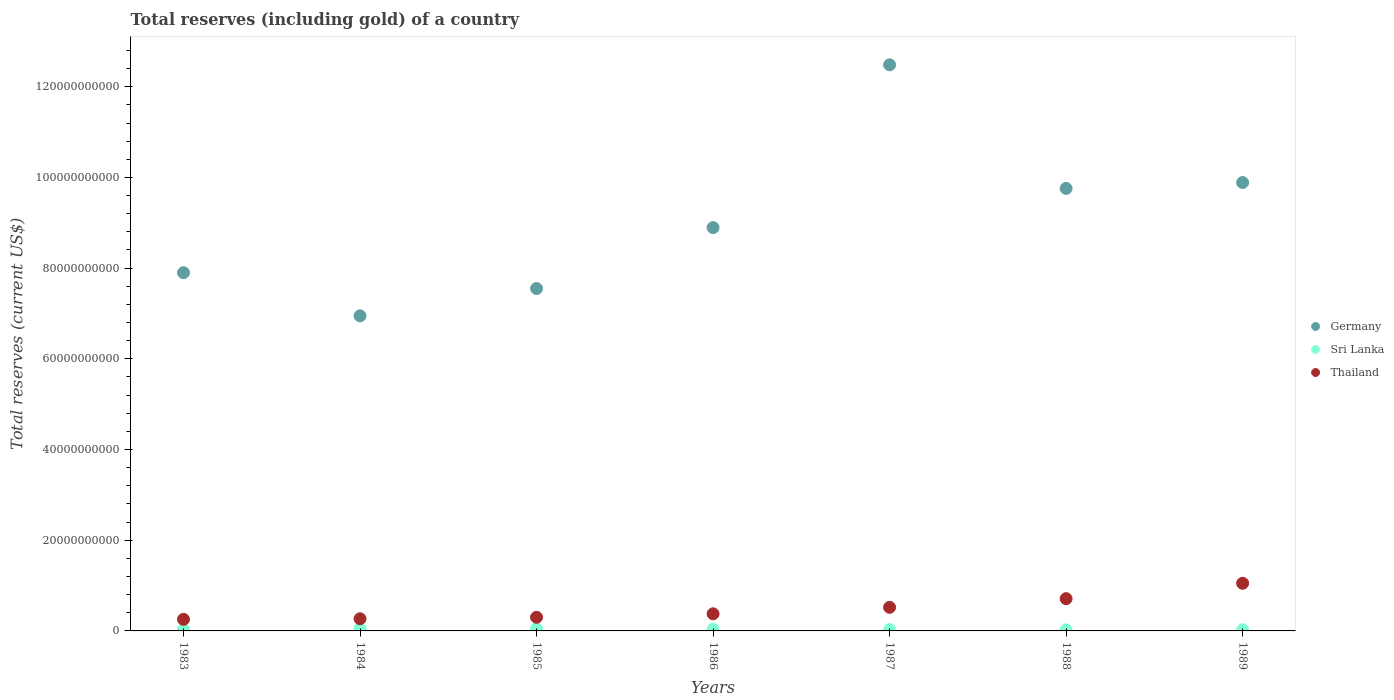Is the number of dotlines equal to the number of legend labels?
Provide a short and direct response. Yes. What is the total reserves (including gold) in Thailand in 1983?
Provide a succinct answer. 2.56e+09. Across all years, what is the maximum total reserves (including gold) in Sri Lanka?
Offer a very short reply. 5.30e+08. Across all years, what is the minimum total reserves (including gold) in Germany?
Your answer should be compact. 6.95e+1. In which year was the total reserves (including gold) in Sri Lanka maximum?
Provide a short and direct response. 1984. In which year was the total reserves (including gold) in Germany minimum?
Your response must be concise. 1984. What is the total total reserves (including gold) in Thailand in the graph?
Your answer should be very brief. 3.48e+1. What is the difference between the total reserves (including gold) in Sri Lanka in 1984 and that in 1986?
Offer a very short reply. 1.53e+08. What is the difference between the total reserves (including gold) in Germany in 1985 and the total reserves (including gold) in Thailand in 1984?
Your answer should be compact. 7.28e+1. What is the average total reserves (including gold) in Thailand per year?
Offer a terse response. 4.98e+09. In the year 1988, what is the difference between the total reserves (including gold) in Sri Lanka and total reserves (including gold) in Germany?
Make the answer very short. -9.73e+1. In how many years, is the total reserves (including gold) in Thailand greater than 8000000000 US$?
Your response must be concise. 1. What is the ratio of the total reserves (including gold) in Sri Lanka in 1986 to that in 1988?
Your answer should be compact. 1.52. What is the difference between the highest and the second highest total reserves (including gold) in Sri Lanka?
Your answer should be compact. 5.84e+07. What is the difference between the highest and the lowest total reserves (including gold) in Sri Lanka?
Your answer should be very brief. 2.82e+08. Is the sum of the total reserves (including gold) in Thailand in 1983 and 1989 greater than the maximum total reserves (including gold) in Sri Lanka across all years?
Give a very brief answer. Yes. Does the total reserves (including gold) in Thailand monotonically increase over the years?
Provide a succinct answer. Yes. How many years are there in the graph?
Offer a very short reply. 7. Does the graph contain any zero values?
Your answer should be compact. No. Does the graph contain grids?
Provide a succinct answer. No. How many legend labels are there?
Offer a terse response. 3. How are the legend labels stacked?
Your response must be concise. Vertical. What is the title of the graph?
Offer a very short reply. Total reserves (including gold) of a country. What is the label or title of the Y-axis?
Offer a terse response. Total reserves (current US$). What is the Total reserves (current US$) of Germany in 1983?
Your response must be concise. 7.90e+1. What is the Total reserves (current US$) in Sri Lanka in 1983?
Offer a very short reply. 3.21e+08. What is the Total reserves (current US$) in Thailand in 1983?
Offer a terse response. 2.56e+09. What is the Total reserves (current US$) of Germany in 1984?
Provide a short and direct response. 6.95e+1. What is the Total reserves (current US$) of Sri Lanka in 1984?
Your answer should be compact. 5.30e+08. What is the Total reserves (current US$) of Thailand in 1984?
Give a very brief answer. 2.69e+09. What is the Total reserves (current US$) of Germany in 1985?
Give a very brief answer. 7.55e+1. What is the Total reserves (current US$) in Sri Lanka in 1985?
Ensure brevity in your answer.  4.72e+08. What is the Total reserves (current US$) in Thailand in 1985?
Offer a terse response. 3.00e+09. What is the Total reserves (current US$) of Germany in 1986?
Offer a very short reply. 8.89e+1. What is the Total reserves (current US$) of Sri Lanka in 1986?
Your response must be concise. 3.77e+08. What is the Total reserves (current US$) of Thailand in 1986?
Give a very brief answer. 3.78e+09. What is the Total reserves (current US$) in Germany in 1987?
Provide a succinct answer. 1.25e+11. What is the Total reserves (current US$) of Sri Lanka in 1987?
Make the answer very short. 3.10e+08. What is the Total reserves (current US$) of Thailand in 1987?
Offer a terse response. 5.21e+09. What is the Total reserves (current US$) of Germany in 1988?
Your response must be concise. 9.76e+1. What is the Total reserves (current US$) in Sri Lanka in 1988?
Your answer should be very brief. 2.48e+08. What is the Total reserves (current US$) in Thailand in 1988?
Provide a succinct answer. 7.11e+09. What is the Total reserves (current US$) of Germany in 1989?
Your answer should be compact. 9.89e+1. What is the Total reserves (current US$) in Sri Lanka in 1989?
Ensure brevity in your answer.  2.69e+08. What is the Total reserves (current US$) in Thailand in 1989?
Provide a succinct answer. 1.05e+1. Across all years, what is the maximum Total reserves (current US$) in Germany?
Your answer should be compact. 1.25e+11. Across all years, what is the maximum Total reserves (current US$) in Sri Lanka?
Your response must be concise. 5.30e+08. Across all years, what is the maximum Total reserves (current US$) of Thailand?
Give a very brief answer. 1.05e+1. Across all years, what is the minimum Total reserves (current US$) of Germany?
Offer a terse response. 6.95e+1. Across all years, what is the minimum Total reserves (current US$) in Sri Lanka?
Give a very brief answer. 2.48e+08. Across all years, what is the minimum Total reserves (current US$) in Thailand?
Keep it short and to the point. 2.56e+09. What is the total Total reserves (current US$) of Germany in the graph?
Give a very brief answer. 6.34e+11. What is the total Total reserves (current US$) in Sri Lanka in the graph?
Provide a short and direct response. 2.53e+09. What is the total Total reserves (current US$) in Thailand in the graph?
Offer a terse response. 3.48e+1. What is the difference between the Total reserves (current US$) in Germany in 1983 and that in 1984?
Your answer should be compact. 9.50e+09. What is the difference between the Total reserves (current US$) in Sri Lanka in 1983 and that in 1984?
Ensure brevity in your answer.  -2.09e+08. What is the difference between the Total reserves (current US$) of Thailand in 1983 and that in 1984?
Offer a terse response. -1.31e+08. What is the difference between the Total reserves (current US$) of Germany in 1983 and that in 1985?
Make the answer very short. 3.48e+09. What is the difference between the Total reserves (current US$) of Sri Lanka in 1983 and that in 1985?
Ensure brevity in your answer.  -1.51e+08. What is the difference between the Total reserves (current US$) of Thailand in 1983 and that in 1985?
Your response must be concise. -4.47e+08. What is the difference between the Total reserves (current US$) in Germany in 1983 and that in 1986?
Provide a short and direct response. -9.95e+09. What is the difference between the Total reserves (current US$) in Sri Lanka in 1983 and that in 1986?
Make the answer very short. -5.62e+07. What is the difference between the Total reserves (current US$) of Thailand in 1983 and that in 1986?
Provide a short and direct response. -1.22e+09. What is the difference between the Total reserves (current US$) in Germany in 1983 and that in 1987?
Ensure brevity in your answer.  -4.58e+1. What is the difference between the Total reserves (current US$) of Sri Lanka in 1983 and that in 1987?
Ensure brevity in your answer.  1.14e+07. What is the difference between the Total reserves (current US$) in Thailand in 1983 and that in 1987?
Offer a very short reply. -2.65e+09. What is the difference between the Total reserves (current US$) in Germany in 1983 and that in 1988?
Your answer should be very brief. -1.86e+1. What is the difference between the Total reserves (current US$) in Sri Lanka in 1983 and that in 1988?
Provide a succinct answer. 7.32e+07. What is the difference between the Total reserves (current US$) of Thailand in 1983 and that in 1988?
Provide a short and direct response. -4.56e+09. What is the difference between the Total reserves (current US$) of Germany in 1983 and that in 1989?
Provide a short and direct response. -1.99e+1. What is the difference between the Total reserves (current US$) in Sri Lanka in 1983 and that in 1989?
Your answer should be compact. 5.15e+07. What is the difference between the Total reserves (current US$) of Thailand in 1983 and that in 1989?
Keep it short and to the point. -7.95e+09. What is the difference between the Total reserves (current US$) of Germany in 1984 and that in 1985?
Your answer should be very brief. -6.02e+09. What is the difference between the Total reserves (current US$) in Sri Lanka in 1984 and that in 1985?
Provide a succinct answer. 5.84e+07. What is the difference between the Total reserves (current US$) of Thailand in 1984 and that in 1985?
Provide a short and direct response. -3.16e+08. What is the difference between the Total reserves (current US$) in Germany in 1984 and that in 1986?
Provide a succinct answer. -1.95e+1. What is the difference between the Total reserves (current US$) of Sri Lanka in 1984 and that in 1986?
Give a very brief answer. 1.53e+08. What is the difference between the Total reserves (current US$) of Thailand in 1984 and that in 1986?
Provide a succinct answer. -1.09e+09. What is the difference between the Total reserves (current US$) in Germany in 1984 and that in 1987?
Provide a short and direct response. -5.53e+1. What is the difference between the Total reserves (current US$) in Sri Lanka in 1984 and that in 1987?
Provide a short and direct response. 2.21e+08. What is the difference between the Total reserves (current US$) in Thailand in 1984 and that in 1987?
Give a very brief answer. -2.52e+09. What is the difference between the Total reserves (current US$) in Germany in 1984 and that in 1988?
Your answer should be compact. -2.81e+1. What is the difference between the Total reserves (current US$) of Sri Lanka in 1984 and that in 1988?
Provide a short and direct response. 2.82e+08. What is the difference between the Total reserves (current US$) of Thailand in 1984 and that in 1988?
Your answer should be compact. -4.43e+09. What is the difference between the Total reserves (current US$) in Germany in 1984 and that in 1989?
Your answer should be compact. -2.94e+1. What is the difference between the Total reserves (current US$) of Sri Lanka in 1984 and that in 1989?
Offer a terse response. 2.61e+08. What is the difference between the Total reserves (current US$) of Thailand in 1984 and that in 1989?
Ensure brevity in your answer.  -7.82e+09. What is the difference between the Total reserves (current US$) in Germany in 1985 and that in 1986?
Offer a very short reply. -1.34e+1. What is the difference between the Total reserves (current US$) in Sri Lanka in 1985 and that in 1986?
Provide a short and direct response. 9.45e+07. What is the difference between the Total reserves (current US$) of Thailand in 1985 and that in 1986?
Your answer should be very brief. -7.73e+08. What is the difference between the Total reserves (current US$) in Germany in 1985 and that in 1987?
Your answer should be compact. -4.93e+1. What is the difference between the Total reserves (current US$) of Sri Lanka in 1985 and that in 1987?
Your answer should be compact. 1.62e+08. What is the difference between the Total reserves (current US$) of Thailand in 1985 and that in 1987?
Offer a very short reply. -2.20e+09. What is the difference between the Total reserves (current US$) in Germany in 1985 and that in 1988?
Keep it short and to the point. -2.21e+1. What is the difference between the Total reserves (current US$) in Sri Lanka in 1985 and that in 1988?
Offer a very short reply. 2.24e+08. What is the difference between the Total reserves (current US$) of Thailand in 1985 and that in 1988?
Ensure brevity in your answer.  -4.11e+09. What is the difference between the Total reserves (current US$) of Germany in 1985 and that in 1989?
Your response must be concise. -2.34e+1. What is the difference between the Total reserves (current US$) in Sri Lanka in 1985 and that in 1989?
Give a very brief answer. 2.02e+08. What is the difference between the Total reserves (current US$) of Thailand in 1985 and that in 1989?
Your answer should be very brief. -7.50e+09. What is the difference between the Total reserves (current US$) of Germany in 1986 and that in 1987?
Provide a short and direct response. -3.59e+1. What is the difference between the Total reserves (current US$) in Sri Lanka in 1986 and that in 1987?
Your answer should be compact. 6.77e+07. What is the difference between the Total reserves (current US$) in Thailand in 1986 and that in 1987?
Provide a succinct answer. -1.43e+09. What is the difference between the Total reserves (current US$) in Germany in 1986 and that in 1988?
Make the answer very short. -8.64e+09. What is the difference between the Total reserves (current US$) of Sri Lanka in 1986 and that in 1988?
Give a very brief answer. 1.29e+08. What is the difference between the Total reserves (current US$) of Thailand in 1986 and that in 1988?
Provide a short and direct response. -3.34e+09. What is the difference between the Total reserves (current US$) in Germany in 1986 and that in 1989?
Your response must be concise. -9.94e+09. What is the difference between the Total reserves (current US$) of Sri Lanka in 1986 and that in 1989?
Make the answer very short. 1.08e+08. What is the difference between the Total reserves (current US$) of Thailand in 1986 and that in 1989?
Your response must be concise. -6.73e+09. What is the difference between the Total reserves (current US$) in Germany in 1987 and that in 1988?
Your answer should be very brief. 2.73e+1. What is the difference between the Total reserves (current US$) of Sri Lanka in 1987 and that in 1988?
Make the answer very short. 6.18e+07. What is the difference between the Total reserves (current US$) in Thailand in 1987 and that in 1988?
Give a very brief answer. -1.91e+09. What is the difference between the Total reserves (current US$) in Germany in 1987 and that in 1989?
Offer a very short reply. 2.60e+1. What is the difference between the Total reserves (current US$) in Sri Lanka in 1987 and that in 1989?
Make the answer very short. 4.01e+07. What is the difference between the Total reserves (current US$) of Thailand in 1987 and that in 1989?
Your response must be concise. -5.30e+09. What is the difference between the Total reserves (current US$) of Germany in 1988 and that in 1989?
Ensure brevity in your answer.  -1.30e+09. What is the difference between the Total reserves (current US$) in Sri Lanka in 1988 and that in 1989?
Offer a terse response. -2.17e+07. What is the difference between the Total reserves (current US$) of Thailand in 1988 and that in 1989?
Keep it short and to the point. -3.40e+09. What is the difference between the Total reserves (current US$) of Germany in 1983 and the Total reserves (current US$) of Sri Lanka in 1984?
Your response must be concise. 7.85e+1. What is the difference between the Total reserves (current US$) of Germany in 1983 and the Total reserves (current US$) of Thailand in 1984?
Your response must be concise. 7.63e+1. What is the difference between the Total reserves (current US$) in Sri Lanka in 1983 and the Total reserves (current US$) in Thailand in 1984?
Your answer should be compact. -2.37e+09. What is the difference between the Total reserves (current US$) of Germany in 1983 and the Total reserves (current US$) of Sri Lanka in 1985?
Give a very brief answer. 7.85e+1. What is the difference between the Total reserves (current US$) in Germany in 1983 and the Total reserves (current US$) in Thailand in 1985?
Your answer should be compact. 7.60e+1. What is the difference between the Total reserves (current US$) of Sri Lanka in 1983 and the Total reserves (current US$) of Thailand in 1985?
Provide a succinct answer. -2.68e+09. What is the difference between the Total reserves (current US$) in Germany in 1983 and the Total reserves (current US$) in Sri Lanka in 1986?
Offer a very short reply. 7.86e+1. What is the difference between the Total reserves (current US$) in Germany in 1983 and the Total reserves (current US$) in Thailand in 1986?
Ensure brevity in your answer.  7.52e+1. What is the difference between the Total reserves (current US$) of Sri Lanka in 1983 and the Total reserves (current US$) of Thailand in 1986?
Your response must be concise. -3.46e+09. What is the difference between the Total reserves (current US$) in Germany in 1983 and the Total reserves (current US$) in Sri Lanka in 1987?
Your response must be concise. 7.87e+1. What is the difference between the Total reserves (current US$) of Germany in 1983 and the Total reserves (current US$) of Thailand in 1987?
Offer a terse response. 7.38e+1. What is the difference between the Total reserves (current US$) of Sri Lanka in 1983 and the Total reserves (current US$) of Thailand in 1987?
Give a very brief answer. -4.88e+09. What is the difference between the Total reserves (current US$) of Germany in 1983 and the Total reserves (current US$) of Sri Lanka in 1988?
Make the answer very short. 7.87e+1. What is the difference between the Total reserves (current US$) in Germany in 1983 and the Total reserves (current US$) in Thailand in 1988?
Provide a short and direct response. 7.19e+1. What is the difference between the Total reserves (current US$) in Sri Lanka in 1983 and the Total reserves (current US$) in Thailand in 1988?
Your response must be concise. -6.79e+09. What is the difference between the Total reserves (current US$) of Germany in 1983 and the Total reserves (current US$) of Sri Lanka in 1989?
Keep it short and to the point. 7.87e+1. What is the difference between the Total reserves (current US$) of Germany in 1983 and the Total reserves (current US$) of Thailand in 1989?
Provide a succinct answer. 6.85e+1. What is the difference between the Total reserves (current US$) in Sri Lanka in 1983 and the Total reserves (current US$) in Thailand in 1989?
Offer a terse response. -1.02e+1. What is the difference between the Total reserves (current US$) of Germany in 1984 and the Total reserves (current US$) of Sri Lanka in 1985?
Ensure brevity in your answer.  6.90e+1. What is the difference between the Total reserves (current US$) in Germany in 1984 and the Total reserves (current US$) in Thailand in 1985?
Ensure brevity in your answer.  6.65e+1. What is the difference between the Total reserves (current US$) of Sri Lanka in 1984 and the Total reserves (current US$) of Thailand in 1985?
Offer a terse response. -2.47e+09. What is the difference between the Total reserves (current US$) in Germany in 1984 and the Total reserves (current US$) in Sri Lanka in 1986?
Keep it short and to the point. 6.91e+1. What is the difference between the Total reserves (current US$) of Germany in 1984 and the Total reserves (current US$) of Thailand in 1986?
Keep it short and to the point. 6.57e+1. What is the difference between the Total reserves (current US$) of Sri Lanka in 1984 and the Total reserves (current US$) of Thailand in 1986?
Provide a short and direct response. -3.25e+09. What is the difference between the Total reserves (current US$) of Germany in 1984 and the Total reserves (current US$) of Sri Lanka in 1987?
Keep it short and to the point. 6.92e+1. What is the difference between the Total reserves (current US$) in Germany in 1984 and the Total reserves (current US$) in Thailand in 1987?
Ensure brevity in your answer.  6.43e+1. What is the difference between the Total reserves (current US$) of Sri Lanka in 1984 and the Total reserves (current US$) of Thailand in 1987?
Offer a very short reply. -4.68e+09. What is the difference between the Total reserves (current US$) in Germany in 1984 and the Total reserves (current US$) in Sri Lanka in 1988?
Your answer should be compact. 6.92e+1. What is the difference between the Total reserves (current US$) in Germany in 1984 and the Total reserves (current US$) in Thailand in 1988?
Your response must be concise. 6.24e+1. What is the difference between the Total reserves (current US$) of Sri Lanka in 1984 and the Total reserves (current US$) of Thailand in 1988?
Provide a short and direct response. -6.58e+09. What is the difference between the Total reserves (current US$) in Germany in 1984 and the Total reserves (current US$) in Sri Lanka in 1989?
Keep it short and to the point. 6.92e+1. What is the difference between the Total reserves (current US$) in Germany in 1984 and the Total reserves (current US$) in Thailand in 1989?
Keep it short and to the point. 5.90e+1. What is the difference between the Total reserves (current US$) in Sri Lanka in 1984 and the Total reserves (current US$) in Thailand in 1989?
Offer a terse response. -9.98e+09. What is the difference between the Total reserves (current US$) of Germany in 1985 and the Total reserves (current US$) of Sri Lanka in 1986?
Offer a terse response. 7.51e+1. What is the difference between the Total reserves (current US$) in Germany in 1985 and the Total reserves (current US$) in Thailand in 1986?
Provide a succinct answer. 7.17e+1. What is the difference between the Total reserves (current US$) in Sri Lanka in 1985 and the Total reserves (current US$) in Thailand in 1986?
Give a very brief answer. -3.30e+09. What is the difference between the Total reserves (current US$) in Germany in 1985 and the Total reserves (current US$) in Sri Lanka in 1987?
Provide a short and direct response. 7.52e+1. What is the difference between the Total reserves (current US$) of Germany in 1985 and the Total reserves (current US$) of Thailand in 1987?
Make the answer very short. 7.03e+1. What is the difference between the Total reserves (current US$) in Sri Lanka in 1985 and the Total reserves (current US$) in Thailand in 1987?
Your response must be concise. -4.73e+09. What is the difference between the Total reserves (current US$) of Germany in 1985 and the Total reserves (current US$) of Sri Lanka in 1988?
Your answer should be very brief. 7.53e+1. What is the difference between the Total reserves (current US$) in Germany in 1985 and the Total reserves (current US$) in Thailand in 1988?
Provide a succinct answer. 6.84e+1. What is the difference between the Total reserves (current US$) of Sri Lanka in 1985 and the Total reserves (current US$) of Thailand in 1988?
Your answer should be compact. -6.64e+09. What is the difference between the Total reserves (current US$) in Germany in 1985 and the Total reserves (current US$) in Sri Lanka in 1989?
Make the answer very short. 7.52e+1. What is the difference between the Total reserves (current US$) in Germany in 1985 and the Total reserves (current US$) in Thailand in 1989?
Offer a very short reply. 6.50e+1. What is the difference between the Total reserves (current US$) in Sri Lanka in 1985 and the Total reserves (current US$) in Thailand in 1989?
Keep it short and to the point. -1.00e+1. What is the difference between the Total reserves (current US$) in Germany in 1986 and the Total reserves (current US$) in Sri Lanka in 1987?
Your answer should be very brief. 8.86e+1. What is the difference between the Total reserves (current US$) in Germany in 1986 and the Total reserves (current US$) in Thailand in 1987?
Keep it short and to the point. 8.37e+1. What is the difference between the Total reserves (current US$) in Sri Lanka in 1986 and the Total reserves (current US$) in Thailand in 1987?
Offer a very short reply. -4.83e+09. What is the difference between the Total reserves (current US$) in Germany in 1986 and the Total reserves (current US$) in Sri Lanka in 1988?
Offer a terse response. 8.87e+1. What is the difference between the Total reserves (current US$) in Germany in 1986 and the Total reserves (current US$) in Thailand in 1988?
Ensure brevity in your answer.  8.18e+1. What is the difference between the Total reserves (current US$) in Sri Lanka in 1986 and the Total reserves (current US$) in Thailand in 1988?
Your answer should be compact. -6.74e+09. What is the difference between the Total reserves (current US$) in Germany in 1986 and the Total reserves (current US$) in Sri Lanka in 1989?
Your answer should be compact. 8.87e+1. What is the difference between the Total reserves (current US$) in Germany in 1986 and the Total reserves (current US$) in Thailand in 1989?
Your response must be concise. 7.84e+1. What is the difference between the Total reserves (current US$) of Sri Lanka in 1986 and the Total reserves (current US$) of Thailand in 1989?
Your answer should be very brief. -1.01e+1. What is the difference between the Total reserves (current US$) of Germany in 1987 and the Total reserves (current US$) of Sri Lanka in 1988?
Keep it short and to the point. 1.25e+11. What is the difference between the Total reserves (current US$) of Germany in 1987 and the Total reserves (current US$) of Thailand in 1988?
Provide a short and direct response. 1.18e+11. What is the difference between the Total reserves (current US$) in Sri Lanka in 1987 and the Total reserves (current US$) in Thailand in 1988?
Offer a terse response. -6.80e+09. What is the difference between the Total reserves (current US$) of Germany in 1987 and the Total reserves (current US$) of Sri Lanka in 1989?
Ensure brevity in your answer.  1.25e+11. What is the difference between the Total reserves (current US$) in Germany in 1987 and the Total reserves (current US$) in Thailand in 1989?
Your response must be concise. 1.14e+11. What is the difference between the Total reserves (current US$) of Sri Lanka in 1987 and the Total reserves (current US$) of Thailand in 1989?
Provide a short and direct response. -1.02e+1. What is the difference between the Total reserves (current US$) in Germany in 1988 and the Total reserves (current US$) in Sri Lanka in 1989?
Give a very brief answer. 9.73e+1. What is the difference between the Total reserves (current US$) in Germany in 1988 and the Total reserves (current US$) in Thailand in 1989?
Offer a very short reply. 8.71e+1. What is the difference between the Total reserves (current US$) in Sri Lanka in 1988 and the Total reserves (current US$) in Thailand in 1989?
Offer a terse response. -1.03e+1. What is the average Total reserves (current US$) in Germany per year?
Your answer should be compact. 9.06e+1. What is the average Total reserves (current US$) in Sri Lanka per year?
Provide a succinct answer. 3.61e+08. What is the average Total reserves (current US$) in Thailand per year?
Keep it short and to the point. 4.98e+09. In the year 1983, what is the difference between the Total reserves (current US$) in Germany and Total reserves (current US$) in Sri Lanka?
Your answer should be compact. 7.87e+1. In the year 1983, what is the difference between the Total reserves (current US$) in Germany and Total reserves (current US$) in Thailand?
Your answer should be very brief. 7.64e+1. In the year 1983, what is the difference between the Total reserves (current US$) of Sri Lanka and Total reserves (current US$) of Thailand?
Your answer should be very brief. -2.23e+09. In the year 1984, what is the difference between the Total reserves (current US$) in Germany and Total reserves (current US$) in Sri Lanka?
Offer a terse response. 6.90e+1. In the year 1984, what is the difference between the Total reserves (current US$) of Germany and Total reserves (current US$) of Thailand?
Your answer should be very brief. 6.68e+1. In the year 1984, what is the difference between the Total reserves (current US$) in Sri Lanka and Total reserves (current US$) in Thailand?
Your response must be concise. -2.16e+09. In the year 1985, what is the difference between the Total reserves (current US$) in Germany and Total reserves (current US$) in Sri Lanka?
Provide a succinct answer. 7.50e+1. In the year 1985, what is the difference between the Total reserves (current US$) of Germany and Total reserves (current US$) of Thailand?
Provide a short and direct response. 7.25e+1. In the year 1985, what is the difference between the Total reserves (current US$) of Sri Lanka and Total reserves (current US$) of Thailand?
Make the answer very short. -2.53e+09. In the year 1986, what is the difference between the Total reserves (current US$) of Germany and Total reserves (current US$) of Sri Lanka?
Offer a very short reply. 8.86e+1. In the year 1986, what is the difference between the Total reserves (current US$) of Germany and Total reserves (current US$) of Thailand?
Your response must be concise. 8.52e+1. In the year 1986, what is the difference between the Total reserves (current US$) of Sri Lanka and Total reserves (current US$) of Thailand?
Provide a succinct answer. -3.40e+09. In the year 1987, what is the difference between the Total reserves (current US$) of Germany and Total reserves (current US$) of Sri Lanka?
Provide a succinct answer. 1.25e+11. In the year 1987, what is the difference between the Total reserves (current US$) of Germany and Total reserves (current US$) of Thailand?
Give a very brief answer. 1.20e+11. In the year 1987, what is the difference between the Total reserves (current US$) of Sri Lanka and Total reserves (current US$) of Thailand?
Your answer should be compact. -4.90e+09. In the year 1988, what is the difference between the Total reserves (current US$) of Germany and Total reserves (current US$) of Sri Lanka?
Offer a terse response. 9.73e+1. In the year 1988, what is the difference between the Total reserves (current US$) of Germany and Total reserves (current US$) of Thailand?
Your response must be concise. 9.05e+1. In the year 1988, what is the difference between the Total reserves (current US$) of Sri Lanka and Total reserves (current US$) of Thailand?
Ensure brevity in your answer.  -6.86e+09. In the year 1989, what is the difference between the Total reserves (current US$) of Germany and Total reserves (current US$) of Sri Lanka?
Your answer should be compact. 9.86e+1. In the year 1989, what is the difference between the Total reserves (current US$) of Germany and Total reserves (current US$) of Thailand?
Provide a short and direct response. 8.84e+1. In the year 1989, what is the difference between the Total reserves (current US$) of Sri Lanka and Total reserves (current US$) of Thailand?
Offer a terse response. -1.02e+1. What is the ratio of the Total reserves (current US$) in Germany in 1983 to that in 1984?
Keep it short and to the point. 1.14. What is the ratio of the Total reserves (current US$) of Sri Lanka in 1983 to that in 1984?
Provide a short and direct response. 0.61. What is the ratio of the Total reserves (current US$) in Thailand in 1983 to that in 1984?
Ensure brevity in your answer.  0.95. What is the ratio of the Total reserves (current US$) in Germany in 1983 to that in 1985?
Offer a very short reply. 1.05. What is the ratio of the Total reserves (current US$) of Sri Lanka in 1983 to that in 1985?
Your answer should be compact. 0.68. What is the ratio of the Total reserves (current US$) of Thailand in 1983 to that in 1985?
Provide a short and direct response. 0.85. What is the ratio of the Total reserves (current US$) of Germany in 1983 to that in 1986?
Provide a succinct answer. 0.89. What is the ratio of the Total reserves (current US$) in Sri Lanka in 1983 to that in 1986?
Your answer should be compact. 0.85. What is the ratio of the Total reserves (current US$) in Thailand in 1983 to that in 1986?
Keep it short and to the point. 0.68. What is the ratio of the Total reserves (current US$) in Germany in 1983 to that in 1987?
Your answer should be compact. 0.63. What is the ratio of the Total reserves (current US$) of Thailand in 1983 to that in 1987?
Your answer should be very brief. 0.49. What is the ratio of the Total reserves (current US$) of Germany in 1983 to that in 1988?
Provide a short and direct response. 0.81. What is the ratio of the Total reserves (current US$) in Sri Lanka in 1983 to that in 1988?
Your answer should be compact. 1.3. What is the ratio of the Total reserves (current US$) of Thailand in 1983 to that in 1988?
Your response must be concise. 0.36. What is the ratio of the Total reserves (current US$) of Germany in 1983 to that in 1989?
Your answer should be compact. 0.8. What is the ratio of the Total reserves (current US$) of Sri Lanka in 1983 to that in 1989?
Offer a terse response. 1.19. What is the ratio of the Total reserves (current US$) of Thailand in 1983 to that in 1989?
Offer a terse response. 0.24. What is the ratio of the Total reserves (current US$) of Germany in 1984 to that in 1985?
Keep it short and to the point. 0.92. What is the ratio of the Total reserves (current US$) of Sri Lanka in 1984 to that in 1985?
Your answer should be compact. 1.12. What is the ratio of the Total reserves (current US$) of Thailand in 1984 to that in 1985?
Your response must be concise. 0.89. What is the ratio of the Total reserves (current US$) in Germany in 1984 to that in 1986?
Offer a very short reply. 0.78. What is the ratio of the Total reserves (current US$) in Sri Lanka in 1984 to that in 1986?
Your answer should be compact. 1.41. What is the ratio of the Total reserves (current US$) in Thailand in 1984 to that in 1986?
Your response must be concise. 0.71. What is the ratio of the Total reserves (current US$) of Germany in 1984 to that in 1987?
Make the answer very short. 0.56. What is the ratio of the Total reserves (current US$) in Sri Lanka in 1984 to that in 1987?
Give a very brief answer. 1.71. What is the ratio of the Total reserves (current US$) of Thailand in 1984 to that in 1987?
Make the answer very short. 0.52. What is the ratio of the Total reserves (current US$) of Germany in 1984 to that in 1988?
Offer a terse response. 0.71. What is the ratio of the Total reserves (current US$) in Sri Lanka in 1984 to that in 1988?
Provide a short and direct response. 2.14. What is the ratio of the Total reserves (current US$) in Thailand in 1984 to that in 1988?
Offer a very short reply. 0.38. What is the ratio of the Total reserves (current US$) in Germany in 1984 to that in 1989?
Your response must be concise. 0.7. What is the ratio of the Total reserves (current US$) in Sri Lanka in 1984 to that in 1989?
Provide a short and direct response. 1.97. What is the ratio of the Total reserves (current US$) in Thailand in 1984 to that in 1989?
Ensure brevity in your answer.  0.26. What is the ratio of the Total reserves (current US$) of Germany in 1985 to that in 1986?
Your response must be concise. 0.85. What is the ratio of the Total reserves (current US$) in Sri Lanka in 1985 to that in 1986?
Offer a terse response. 1.25. What is the ratio of the Total reserves (current US$) in Thailand in 1985 to that in 1986?
Your response must be concise. 0.8. What is the ratio of the Total reserves (current US$) of Germany in 1985 to that in 1987?
Your answer should be compact. 0.6. What is the ratio of the Total reserves (current US$) in Sri Lanka in 1985 to that in 1987?
Your answer should be very brief. 1.52. What is the ratio of the Total reserves (current US$) in Thailand in 1985 to that in 1987?
Your answer should be compact. 0.58. What is the ratio of the Total reserves (current US$) in Germany in 1985 to that in 1988?
Ensure brevity in your answer.  0.77. What is the ratio of the Total reserves (current US$) of Sri Lanka in 1985 to that in 1988?
Offer a very short reply. 1.9. What is the ratio of the Total reserves (current US$) of Thailand in 1985 to that in 1988?
Offer a very short reply. 0.42. What is the ratio of the Total reserves (current US$) in Germany in 1985 to that in 1989?
Provide a succinct answer. 0.76. What is the ratio of the Total reserves (current US$) of Sri Lanka in 1985 to that in 1989?
Provide a short and direct response. 1.75. What is the ratio of the Total reserves (current US$) in Thailand in 1985 to that in 1989?
Provide a short and direct response. 0.29. What is the ratio of the Total reserves (current US$) in Germany in 1986 to that in 1987?
Keep it short and to the point. 0.71. What is the ratio of the Total reserves (current US$) of Sri Lanka in 1986 to that in 1987?
Your answer should be very brief. 1.22. What is the ratio of the Total reserves (current US$) in Thailand in 1986 to that in 1987?
Offer a very short reply. 0.73. What is the ratio of the Total reserves (current US$) in Germany in 1986 to that in 1988?
Provide a succinct answer. 0.91. What is the ratio of the Total reserves (current US$) in Sri Lanka in 1986 to that in 1988?
Keep it short and to the point. 1.52. What is the ratio of the Total reserves (current US$) of Thailand in 1986 to that in 1988?
Make the answer very short. 0.53. What is the ratio of the Total reserves (current US$) in Germany in 1986 to that in 1989?
Provide a short and direct response. 0.9. What is the ratio of the Total reserves (current US$) of Sri Lanka in 1986 to that in 1989?
Keep it short and to the point. 1.4. What is the ratio of the Total reserves (current US$) in Thailand in 1986 to that in 1989?
Make the answer very short. 0.36. What is the ratio of the Total reserves (current US$) of Germany in 1987 to that in 1988?
Your answer should be very brief. 1.28. What is the ratio of the Total reserves (current US$) of Sri Lanka in 1987 to that in 1988?
Make the answer very short. 1.25. What is the ratio of the Total reserves (current US$) in Thailand in 1987 to that in 1988?
Your answer should be compact. 0.73. What is the ratio of the Total reserves (current US$) of Germany in 1987 to that in 1989?
Offer a very short reply. 1.26. What is the ratio of the Total reserves (current US$) in Sri Lanka in 1987 to that in 1989?
Ensure brevity in your answer.  1.15. What is the ratio of the Total reserves (current US$) of Thailand in 1987 to that in 1989?
Ensure brevity in your answer.  0.5. What is the ratio of the Total reserves (current US$) of Sri Lanka in 1988 to that in 1989?
Provide a short and direct response. 0.92. What is the ratio of the Total reserves (current US$) of Thailand in 1988 to that in 1989?
Offer a very short reply. 0.68. What is the difference between the highest and the second highest Total reserves (current US$) in Germany?
Keep it short and to the point. 2.60e+1. What is the difference between the highest and the second highest Total reserves (current US$) in Sri Lanka?
Your answer should be very brief. 5.84e+07. What is the difference between the highest and the second highest Total reserves (current US$) in Thailand?
Ensure brevity in your answer.  3.40e+09. What is the difference between the highest and the lowest Total reserves (current US$) of Germany?
Keep it short and to the point. 5.53e+1. What is the difference between the highest and the lowest Total reserves (current US$) in Sri Lanka?
Keep it short and to the point. 2.82e+08. What is the difference between the highest and the lowest Total reserves (current US$) in Thailand?
Your response must be concise. 7.95e+09. 